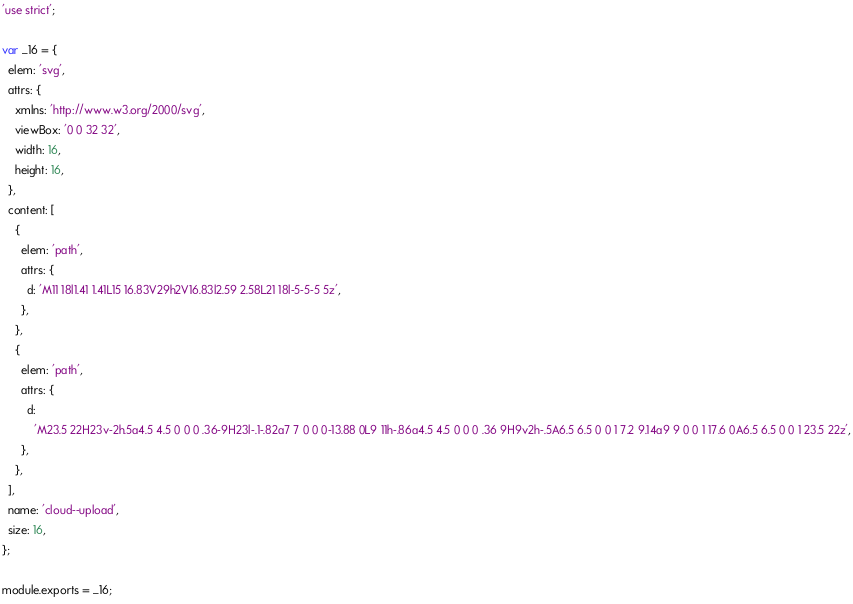<code> <loc_0><loc_0><loc_500><loc_500><_JavaScript_>'use strict';

var _16 = {
  elem: 'svg',
  attrs: {
    xmlns: 'http://www.w3.org/2000/svg',
    viewBox: '0 0 32 32',
    width: 16,
    height: 16,
  },
  content: [
    {
      elem: 'path',
      attrs: {
        d: 'M11 18l1.41 1.41L15 16.83V29h2V16.83l2.59 2.58L21 18l-5-5-5 5z',
      },
    },
    {
      elem: 'path',
      attrs: {
        d:
          'M23.5 22H23v-2h.5a4.5 4.5 0 0 0 .36-9H23l-.1-.82a7 7 0 0 0-13.88 0L9 11h-.86a4.5 4.5 0 0 0 .36 9H9v2h-.5A6.5 6.5 0 0 1 7.2 9.14a9 9 0 0 1 17.6 0A6.5 6.5 0 0 1 23.5 22z',
      },
    },
  ],
  name: 'cloud--upload',
  size: 16,
};

module.exports = _16;
</code> 